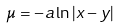<formula> <loc_0><loc_0><loc_500><loc_500>\mu = - a \ln | x - y |</formula> 